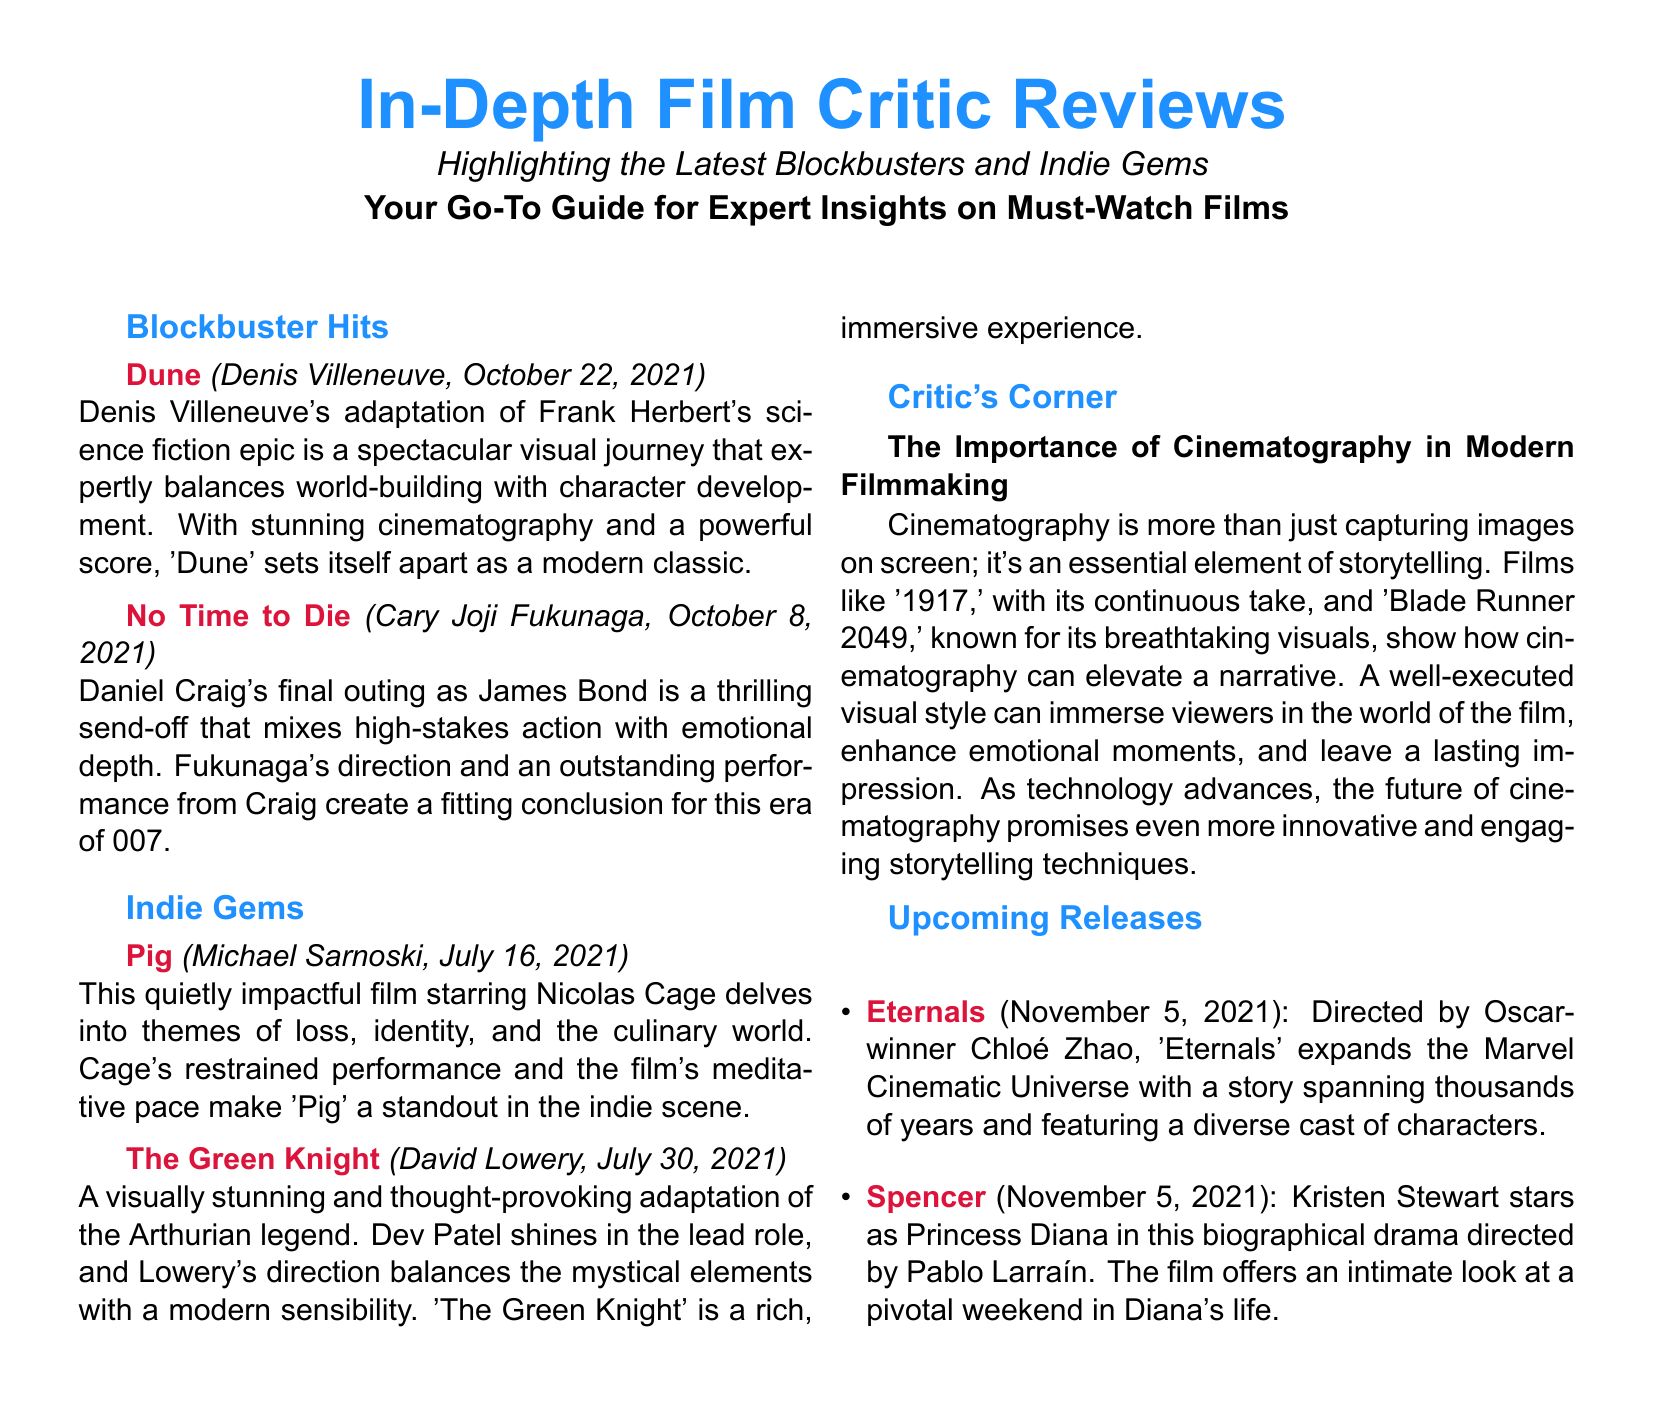What is the premiere date of "Dune"? The premiere date for "Dune" is mentioned at the beginning of its review as October 22, 2021.
Answer: October 22, 2021 Who directed "The Green Knight"? The document specifies that "The Green Knight" was directed by David Lowery.
Answer: David Lowery What themes does "Pig" explore? The review for "Pig" states that the film delves into themes of loss, identity, and the culinary world.
Answer: Loss, identity, culinary world Which film features Kristen Stewart as Princess Diana? The upcoming releases section indicates that "Spencer" features Kristen Stewart as Princess Diana.
Answer: Spencer How does the review characterize "No Time to Die"? The review describes "No Time to Die" as a thrilling send-off that mixes high-stakes action with emotional depth.
Answer: Thrilling send-off mixing action and emotional depth What is the significance of cinematography according to the Critic's Corner? The importance of cinematography is highlighted as an essential element of storytelling that can immerse viewers in the film's world.
Answer: Essential element of storytelling What is the genre of "Eternals"? "Eternals" is part of the Marvel Cinematic Universe and is indicated to have a narrative spanning thousands of years.
Answer: Marvel Cinematic Universe Which actor stars in "Pig"? The review for "Pig" mentions that Nicolas Cage stars in this film.
Answer: Nicolas Cage 